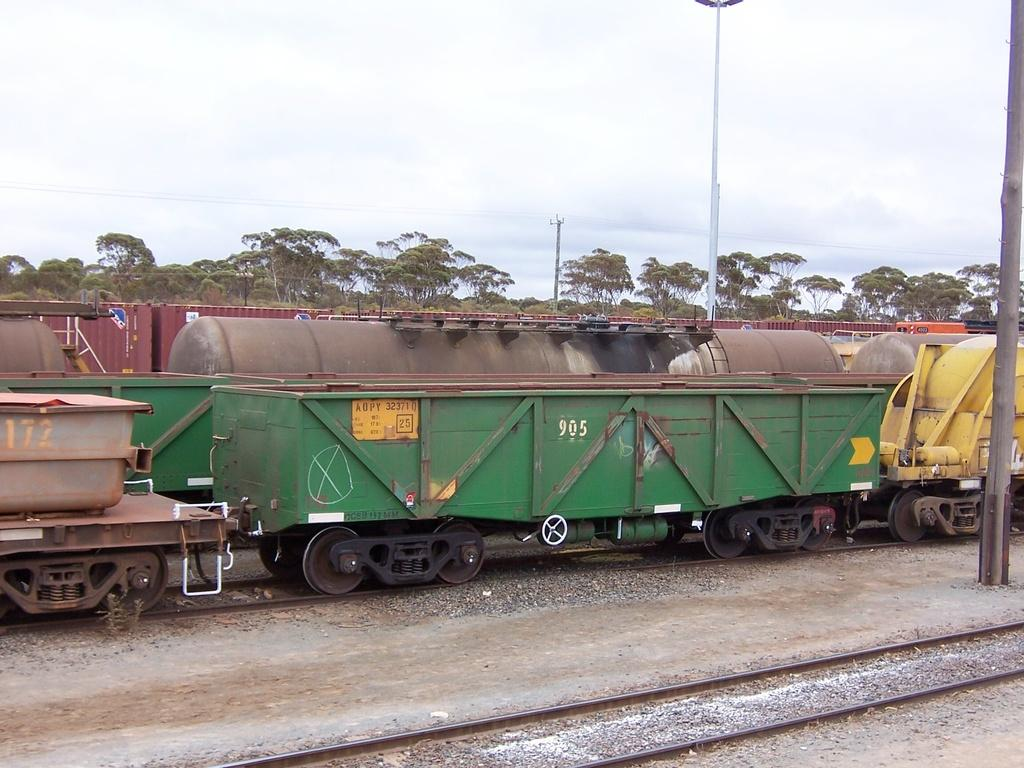What type of vehicles are in the image? There are trains in the image. Where are the trains located? The trains are on railway tracks. What colors can be seen on the trains? The trains are in different colors. What can be seen in the background of the image? There are trees and poles visible in the background. How would you describe the sky in the image? The sky is a combination of white and blue colors. Can you see a coil of rope on the seashore in the image? There is no seashore or coil of rope present in the image; it features trains on railway tracks with a background of trees, poles, and a white and blue sky. 